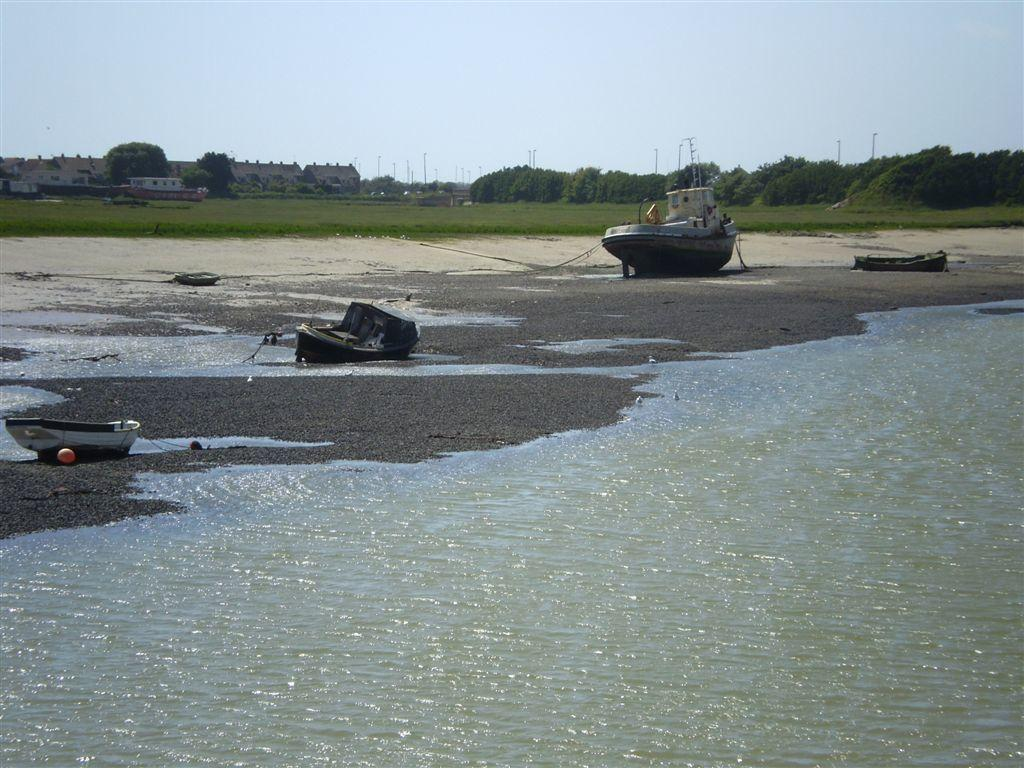What type of vehicles can be seen in the image? There are boats in the image. What is the primary setting of the image? The image contains a body of water (sea). What type of vegetation is visible in the image? There are trees, plants, and grass present in the image. What architectural features can be seen in the background of the image? There are poles and houses in the background of the image. Reasoning: Let'ing: Let's think step by step in order to produce the conversation. We start by identifying the main subject in the image, which are the boats. Then, we expand the conversation to include other elements of the image, such as the body of water, vegetation, and architectural features. Each question is designed to elicit a specific detail about the image that is known from the provided facts. Absurd Question/Answer: How many eggs does the hen in the image have? There is no hen present in the image. What type of giants can be seen in the image? There are no giants present in the image. 